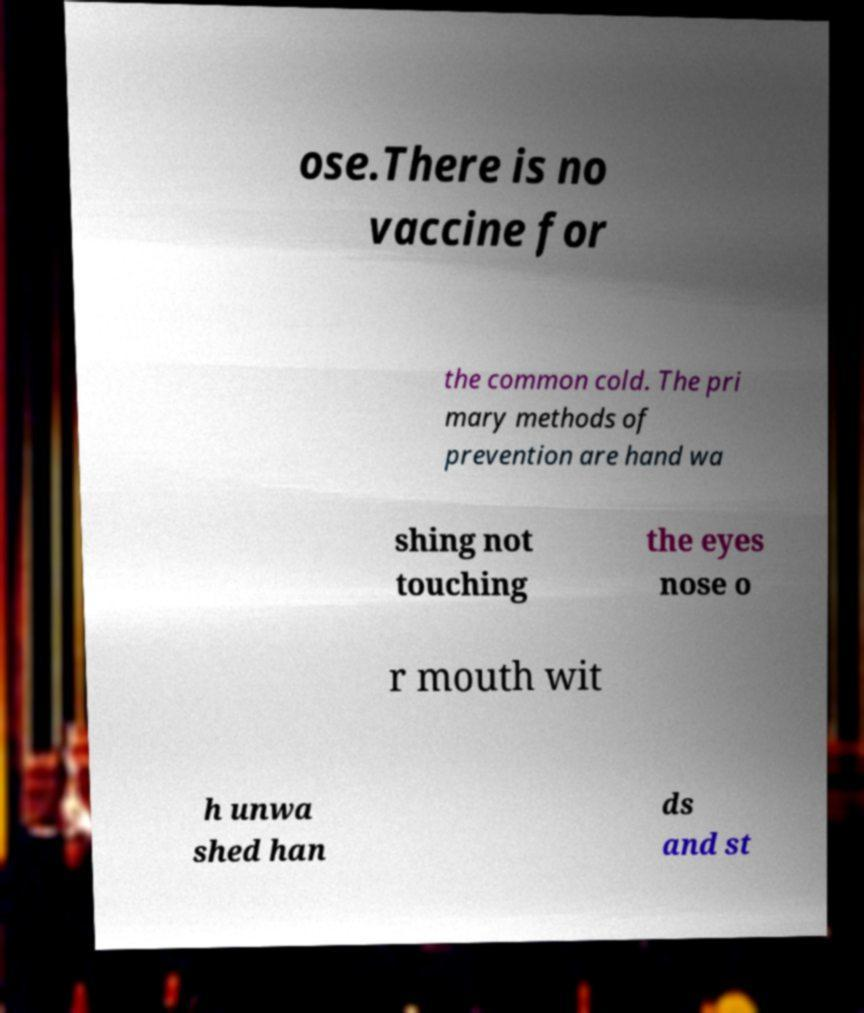Can you read and provide the text displayed in the image?This photo seems to have some interesting text. Can you extract and type it out for me? ose.There is no vaccine for the common cold. The pri mary methods of prevention are hand wa shing not touching the eyes nose o r mouth wit h unwa shed han ds and st 